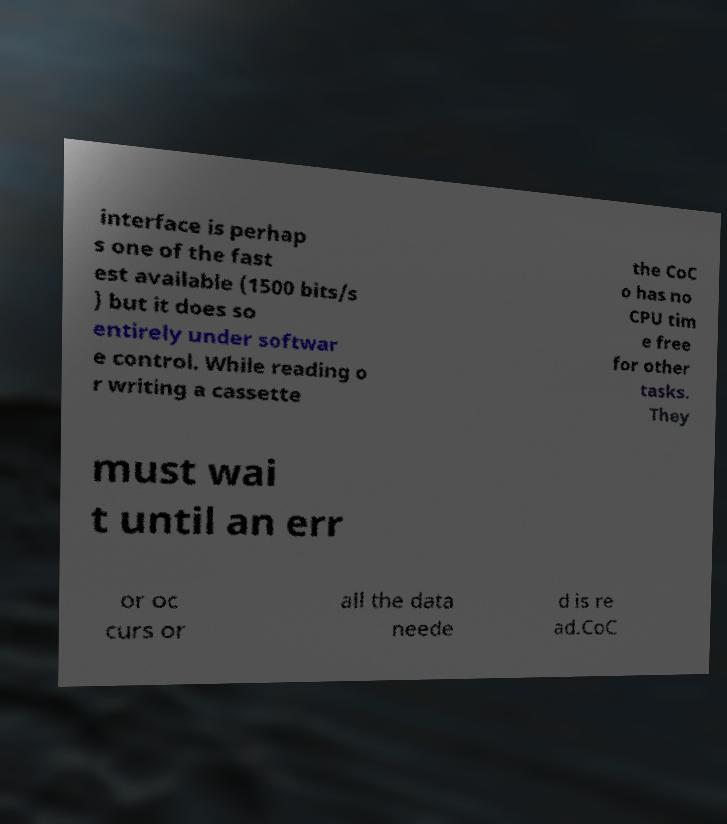Can you accurately transcribe the text from the provided image for me? interface is perhap s one of the fast est available (1500 bits/s ) but it does so entirely under softwar e control. While reading o r writing a cassette the CoC o has no CPU tim e free for other tasks. They must wai t until an err or oc curs or all the data neede d is re ad.CoC 